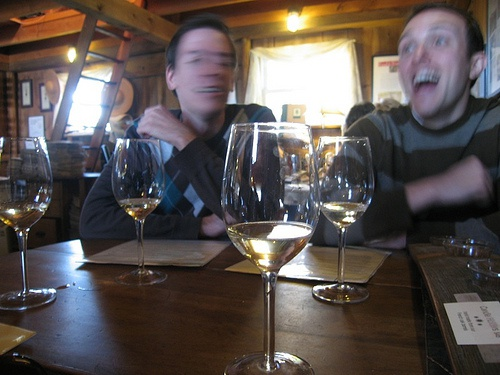Describe the objects in this image and their specific colors. I can see dining table in black and gray tones, people in black, gray, and blue tones, wine glass in black, gray, and white tones, people in black, gray, darkgray, and navy tones, and wine glass in black, gray, white, and darkgray tones in this image. 